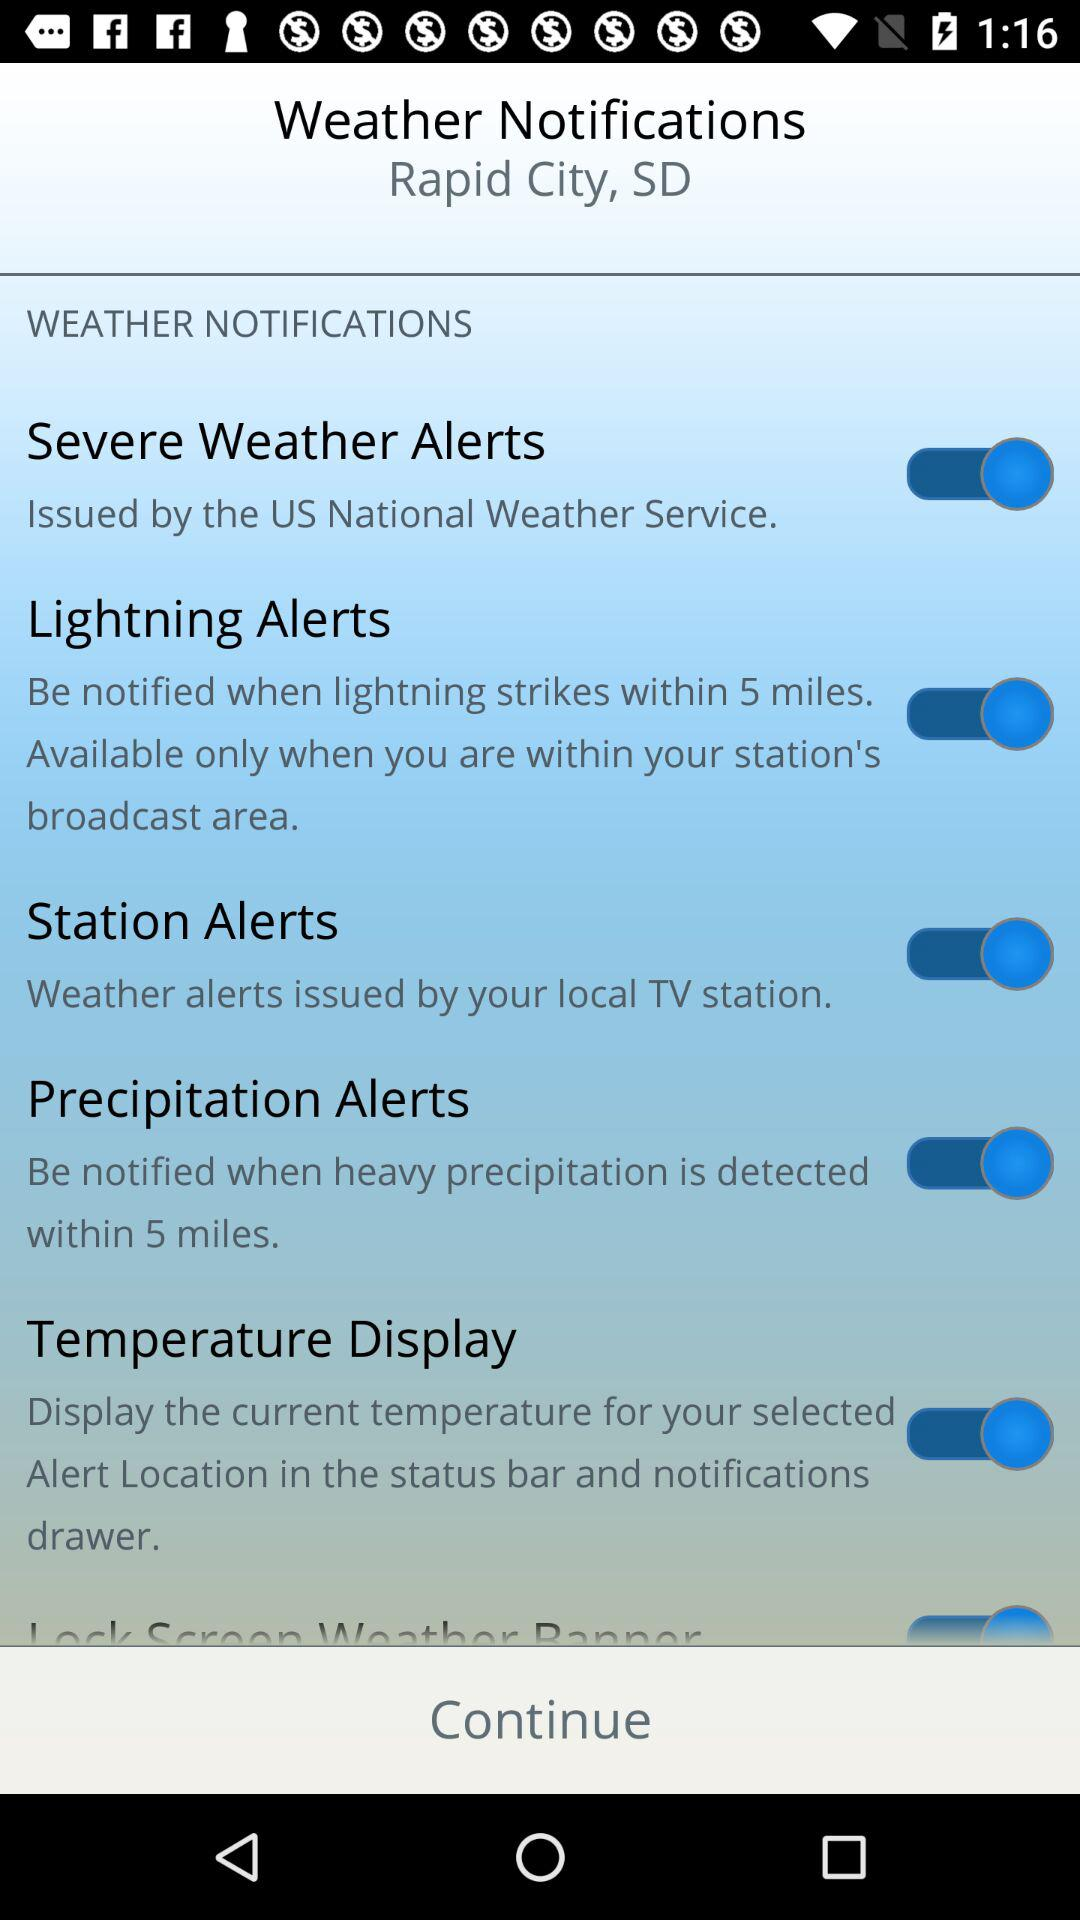Within what range will the precipitation alerts be given? The precipitation alerts will be given within 5 miles. 